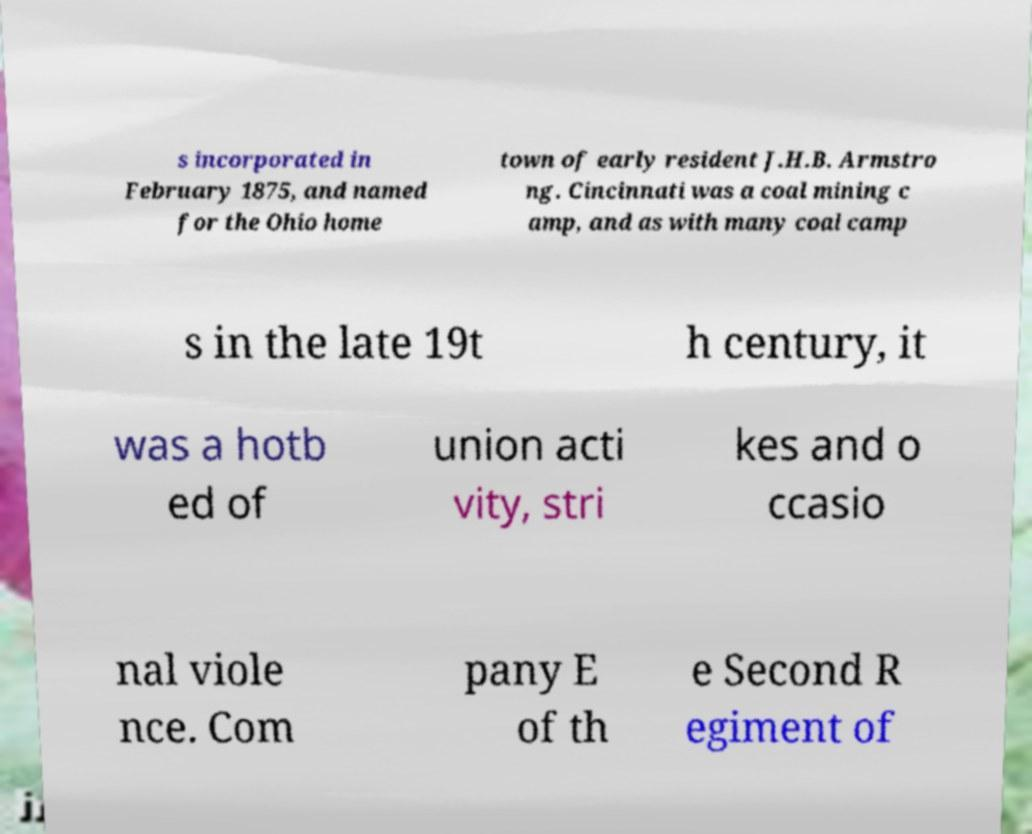Can you accurately transcribe the text from the provided image for me? s incorporated in February 1875, and named for the Ohio home town of early resident J.H.B. Armstro ng. Cincinnati was a coal mining c amp, and as with many coal camp s in the late 19t h century, it was a hotb ed of union acti vity, stri kes and o ccasio nal viole nce. Com pany E of th e Second R egiment of 